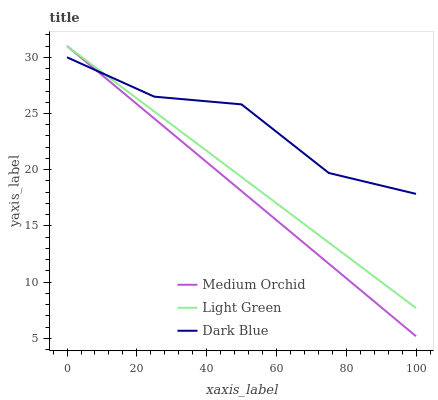Does Medium Orchid have the minimum area under the curve?
Answer yes or no. Yes. Does Dark Blue have the maximum area under the curve?
Answer yes or no. Yes. Does Light Green have the minimum area under the curve?
Answer yes or no. No. Does Light Green have the maximum area under the curve?
Answer yes or no. No. Is Medium Orchid the smoothest?
Answer yes or no. Yes. Is Dark Blue the roughest?
Answer yes or no. Yes. Is Light Green the smoothest?
Answer yes or no. No. Is Light Green the roughest?
Answer yes or no. No. Does Medium Orchid have the lowest value?
Answer yes or no. Yes. Does Light Green have the lowest value?
Answer yes or no. No. Does Light Green have the highest value?
Answer yes or no. Yes. Does Dark Blue intersect Medium Orchid?
Answer yes or no. Yes. Is Dark Blue less than Medium Orchid?
Answer yes or no. No. Is Dark Blue greater than Medium Orchid?
Answer yes or no. No. 